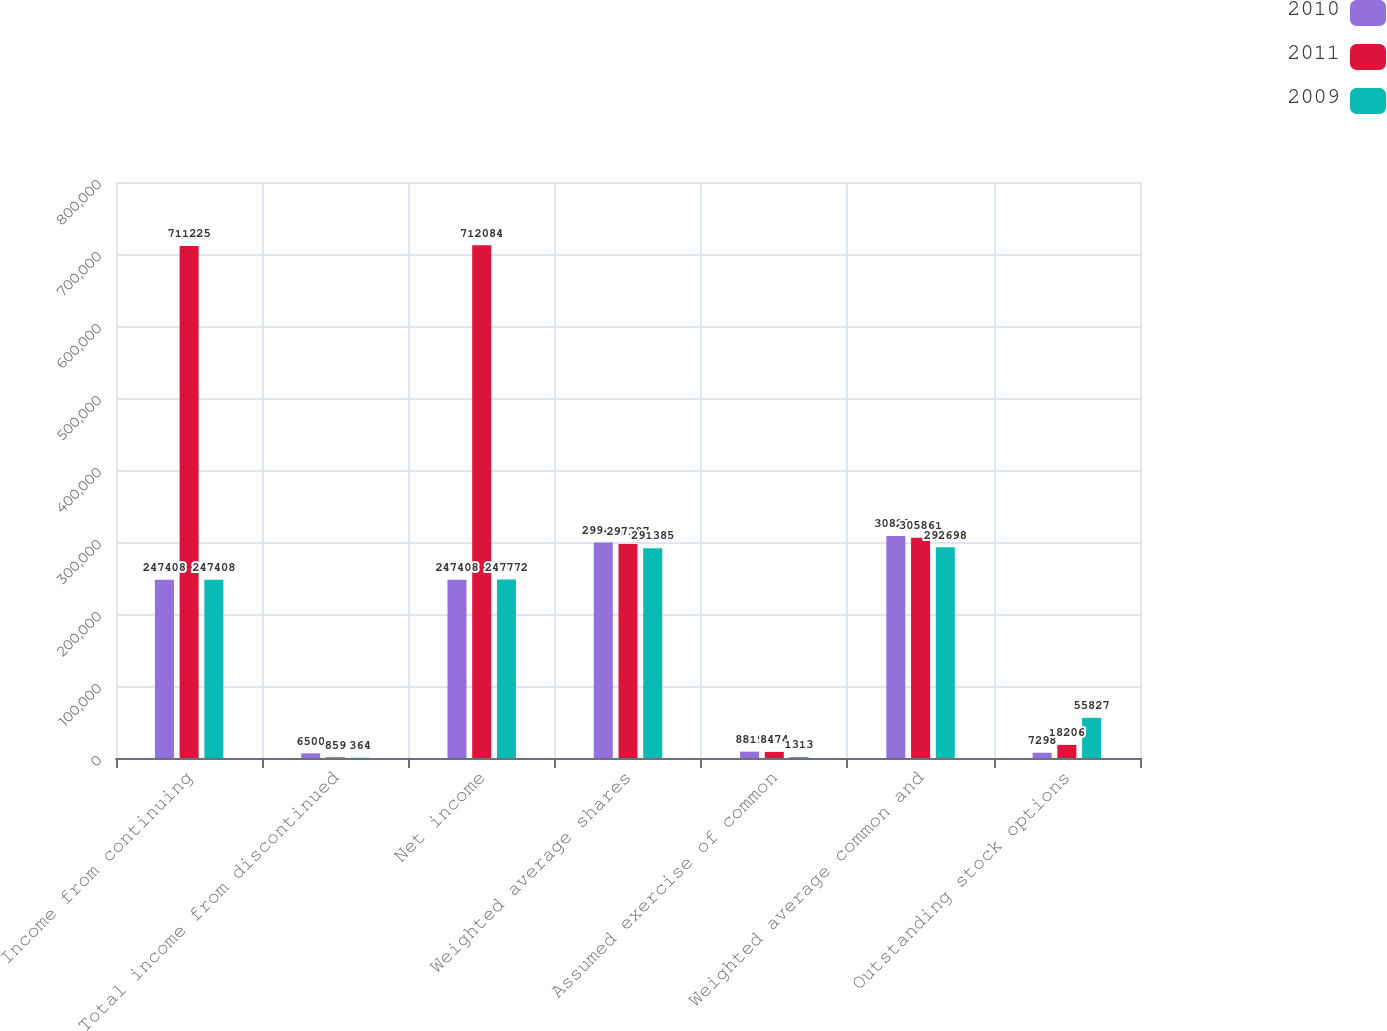Convert chart to OTSL. <chart><loc_0><loc_0><loc_500><loc_500><stacked_bar_chart><ecel><fcel>Income from continuing<fcel>Total income from discontinued<fcel>Net income<fcel>Weighted average shares<fcel>Assumed exercise of common<fcel>Weighted average common and<fcel>Outstanding stock options<nl><fcel>2010<fcel>247408<fcel>6500<fcel>247408<fcel>299417<fcel>8819<fcel>308236<fcel>7298<nl><fcel>2011<fcel>711225<fcel>859<fcel>712084<fcel>297387<fcel>8474<fcel>305861<fcel>18206<nl><fcel>2009<fcel>247408<fcel>364<fcel>247772<fcel>291385<fcel>1313<fcel>292698<fcel>55827<nl></chart> 